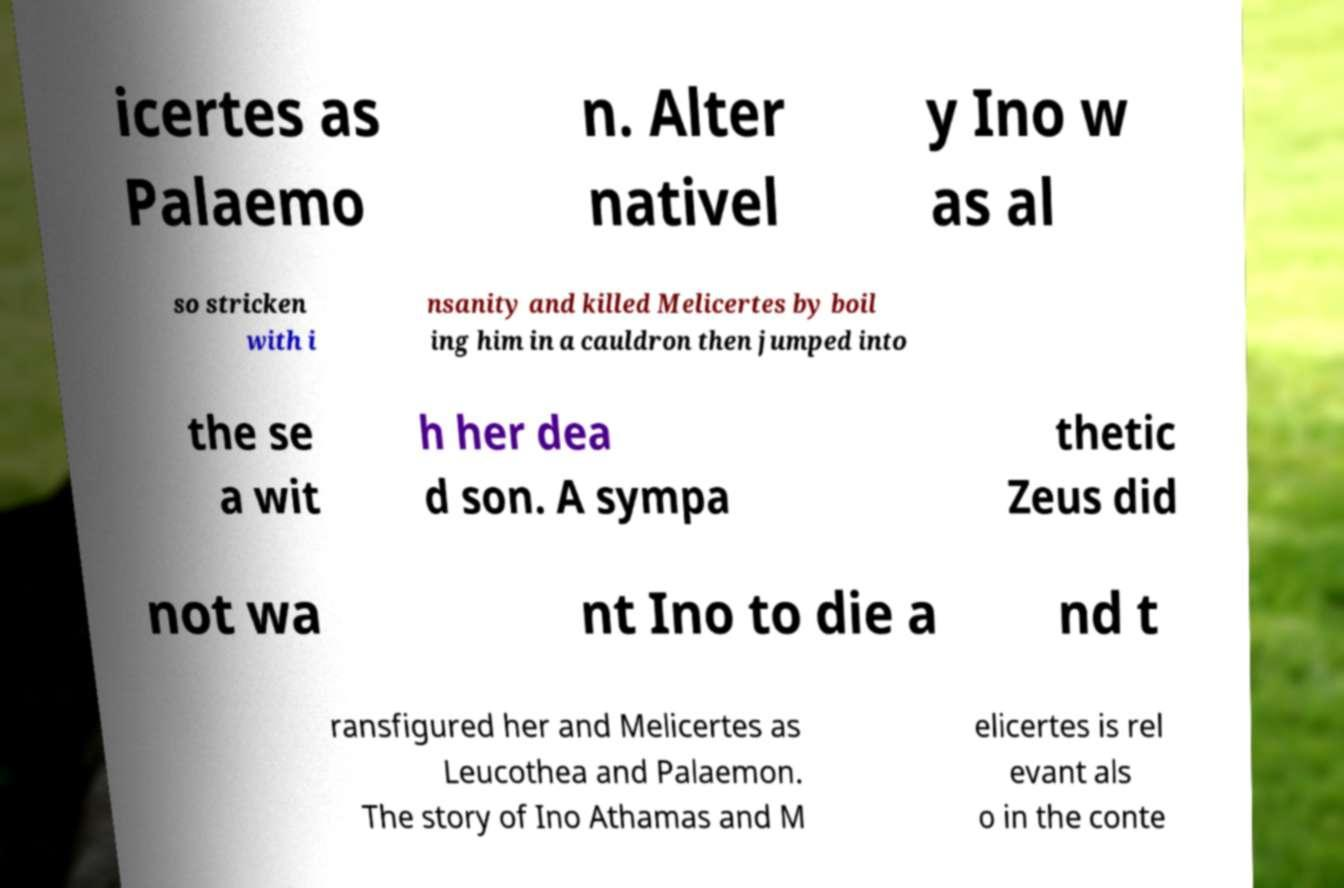Please identify and transcribe the text found in this image. icertes as Palaemo n. Alter nativel y Ino w as al so stricken with i nsanity and killed Melicertes by boil ing him in a cauldron then jumped into the se a wit h her dea d son. A sympa thetic Zeus did not wa nt Ino to die a nd t ransfigured her and Melicertes as Leucothea and Palaemon. The story of Ino Athamas and M elicertes is rel evant als o in the conte 